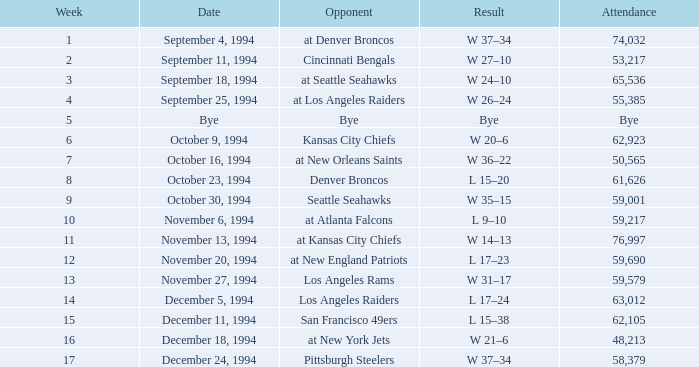Which team was the competitor in the game occurring on or before week 9 with a crowd of 61,626 spectators? Denver Broncos. 